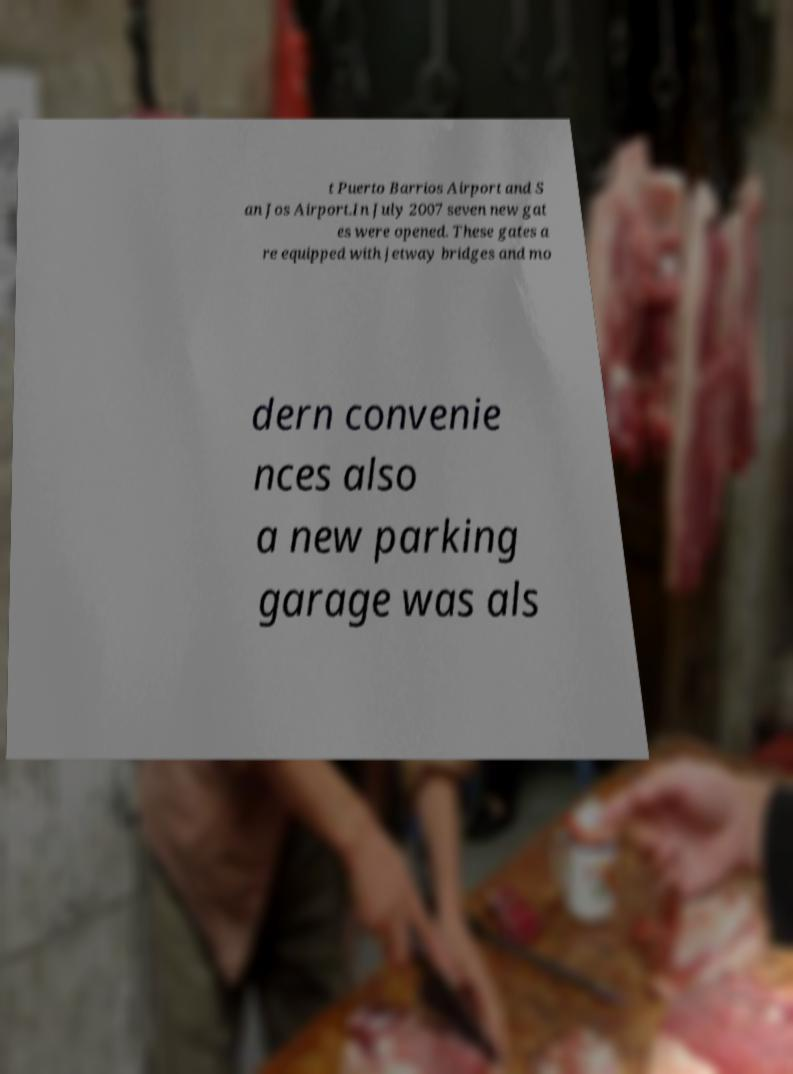Can you accurately transcribe the text from the provided image for me? t Puerto Barrios Airport and S an Jos Airport.In July 2007 seven new gat es were opened. These gates a re equipped with jetway bridges and mo dern convenie nces also a new parking garage was als 